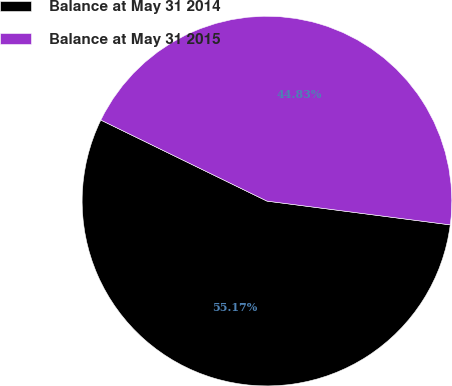Convert chart. <chart><loc_0><loc_0><loc_500><loc_500><pie_chart><fcel>Balance at May 31 2014<fcel>Balance at May 31 2015<nl><fcel>55.17%<fcel>44.83%<nl></chart> 